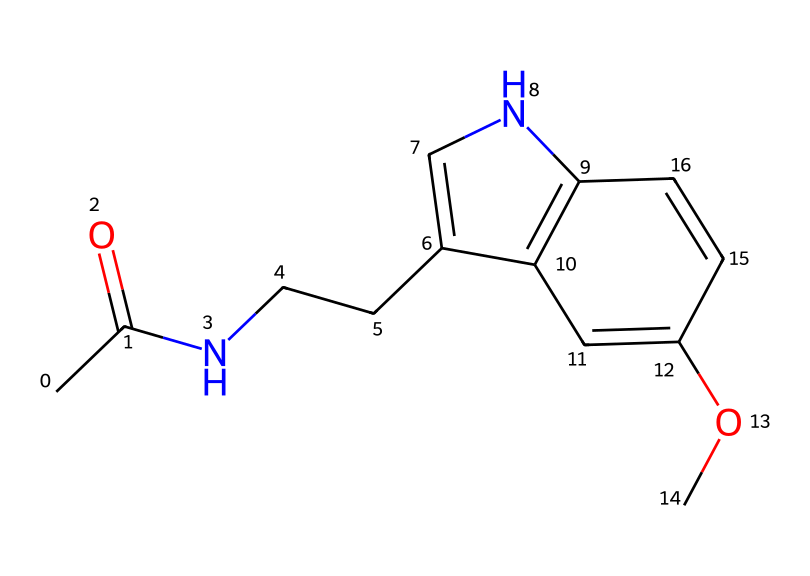What is the molecular formula of this compound? To determine the molecular formula, we count the number of each type of atom in the chemical structure. The SMILES representation indicates the presence of: carbon (C), hydrogen (H), oxygen (O), and nitrogen (N). Counting gives 13 carbons, 17 hydrogens, 1 nitrogen, and 2 oxygens. Thus, the molecular formula is C13H17N2O2.
Answer: C13H17N2O2 How many rings does the structure contain? By analyzing the SMILES representation, we look for numbers indicating ring connections. The presence of '1' and '2' suggests that there are two points of connection indicating ring formations. Thus, counting these connections implies that there are two rings present in the structure.
Answer: 2 What class of hormones does melatonin belong to? Melatonin is classified as an indoleamine hormone based on its structure, which contains an indole ring system. This classification stems from its biosynthesis from the amino acid tryptophan, which prominently features the indole structure.
Answer: indoleamine What is the significance of the nitrogen atom in this structure? The nitrogen atom in this structure is essential as it contributes to the basic properties of melatonin, particularly its function as a signaling molecule in the body. Nitrogen in organic substances often influences their reactivity and biological interactions.
Answer: signaling molecule Which functional group is indicated by "C(=O)" in the structure? The "C(=O)" notates a carbon atom double bonded to an oxygen atom, which is characteristic of a carbonyl group. This functional group is significant in altering the chemical properties and reactivity of the compound, impacting its biological function.
Answer: carbonyl group 